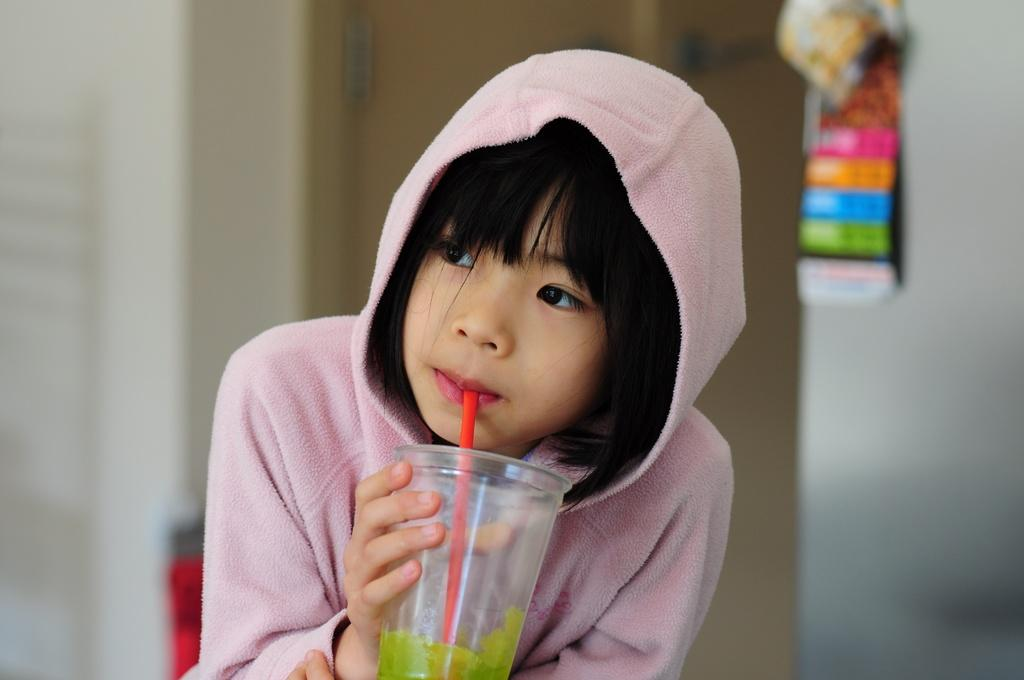Who is present in the image? There is a person in the image. What is the person doing in the image? The person is having a drink. Can you describe any objects or features on the wall in the image? There is an object on a wall in the image. What is located behind the person in the image? There is a door behind the person in the image. What type of business is being conducted in the image? There is no indication of any business being conducted in the image. Can you see a train in the image? There is no train present in the image. 